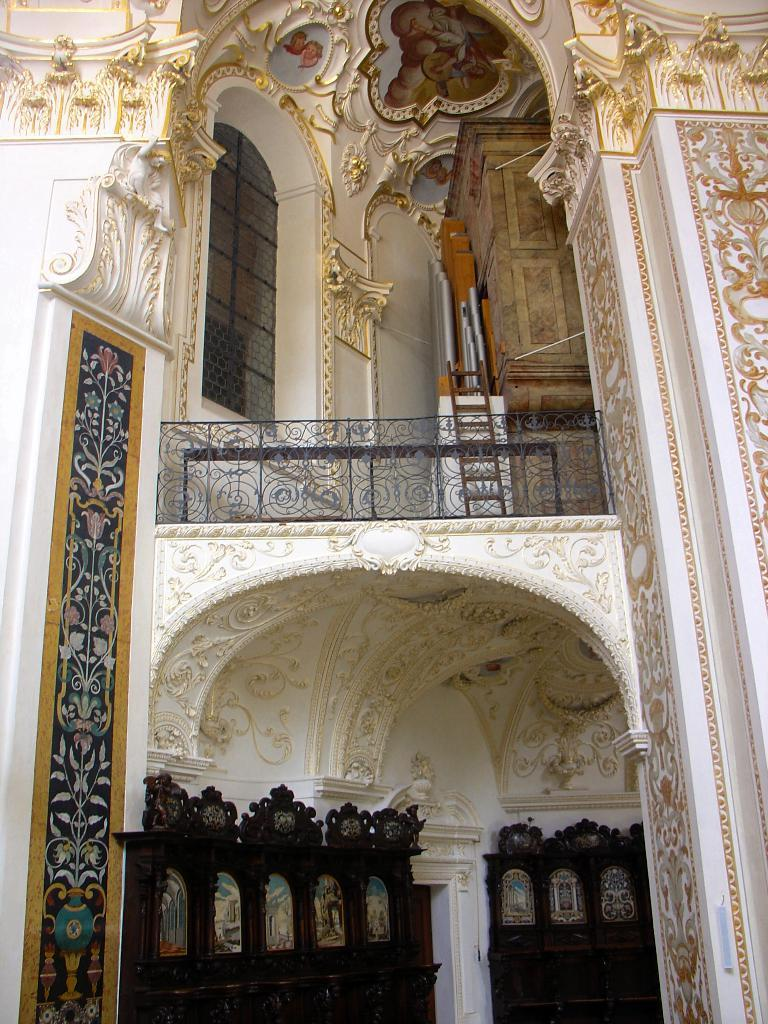What is one of the main features of the image? There is a wall in the image. What can be seen on the wall? There are photos on the wall. Are there any unique details on the wall? Yes, there are carvings in the image. What type of architectural feature is present in the image? There is a railing in the image. What material is visible in the image? There is a mesh in the image. Can you describe any other objects present in the image? There are other objects present in the image, but their specific details are not mentioned in the provided facts. How many thumbs can be seen in the image? There is no mention of thumbs in the provided facts, so it cannot be determined from the image. 